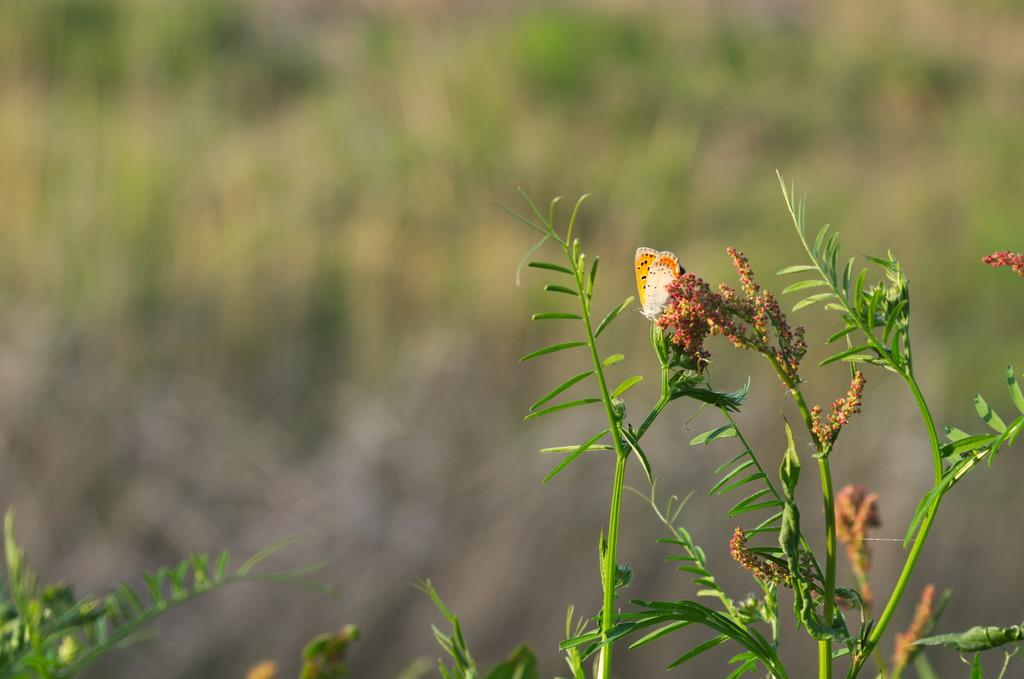What is located at the bottom of the picture? There are plants at the bottom of the picture. What is on the plant? A butterfly is on the plant. Can you describe the butterfly's appearance? The butterfly has white and orange colors. What can be seen in the background of the image? The background of the image is green and blurred. How many houses are connected by the train in the image? There are no houses or trains present in the image; it features plants and a butterfly. What type of connection does the butterfly have with the train in the image? There is no train present in the image, so the butterfly cannot have any connection with it. 